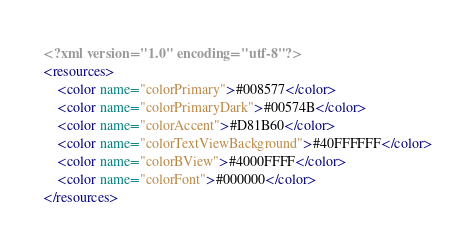Convert code to text. <code><loc_0><loc_0><loc_500><loc_500><_XML_><?xml version="1.0" encoding="utf-8"?>
<resources>
    <color name="colorPrimary">#008577</color>
    <color name="colorPrimaryDark">#00574B</color>
    <color name="colorAccent">#D81B60</color>
    <color name="colorTextViewBackground">#40FFFFFF</color>
    <color name="colorBView">#4000FFFF</color>
    <color name="colorFont">#000000</color>
</resources>
</code> 